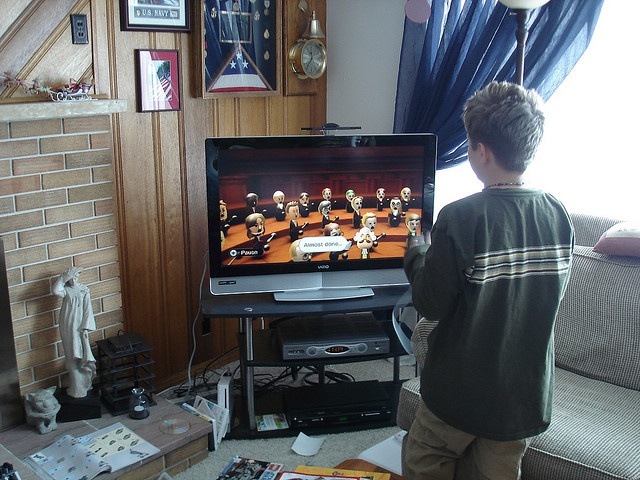Describe the objects in this image and their specific colors. I can see people in darkgray, black, gray, and darkblue tones, tv in darkgray, black, maroon, gray, and orange tones, tv in darkgray, black, maroon, white, and orange tones, couch in darkgray, gray, and black tones, and book in darkgray, gray, and lightblue tones in this image. 